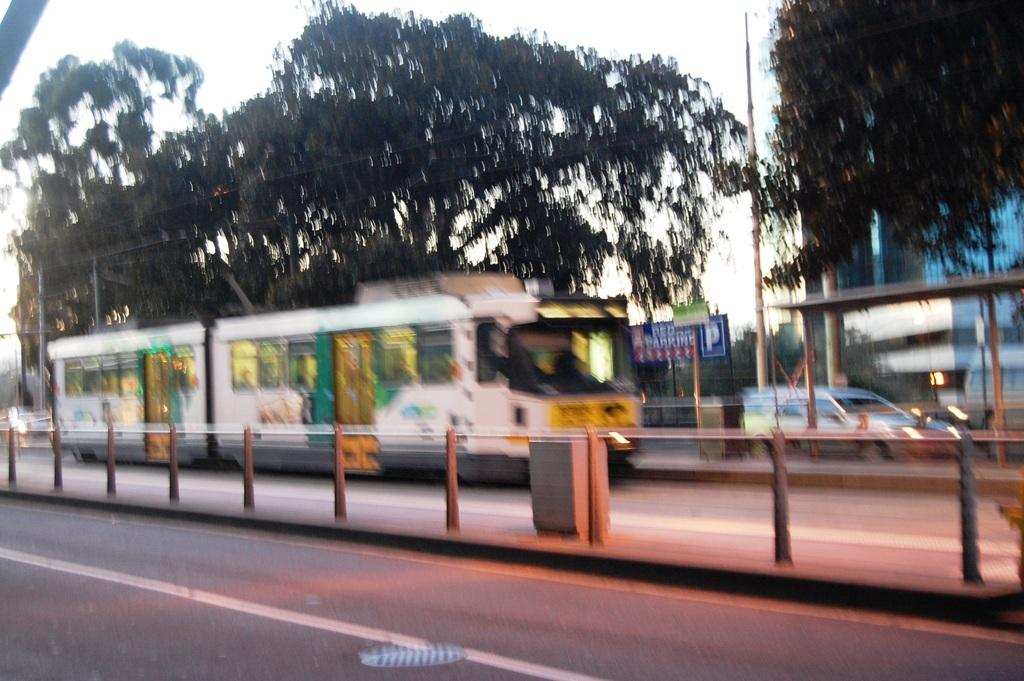What separates the different areas in the image? There is a divider in the image. What can be seen on the road in the image? There are vehicles on the road in the image. What is the color of the vehicle in front? The color of the vehicle in front is white. What type of vegetation is present in the image? There are trees in the image, and they are green. What type of structure is visible in the image? There is a building in the image. What is visible in the sky in the image? The sky is visible in the image, and it appears to be white. Where is the vase located in the image? There is no vase present in the image. What type of room is visible in the image? The image does not show a room; it is an outdoor scene with a road, vehicles, trees, a building, and a sky. 